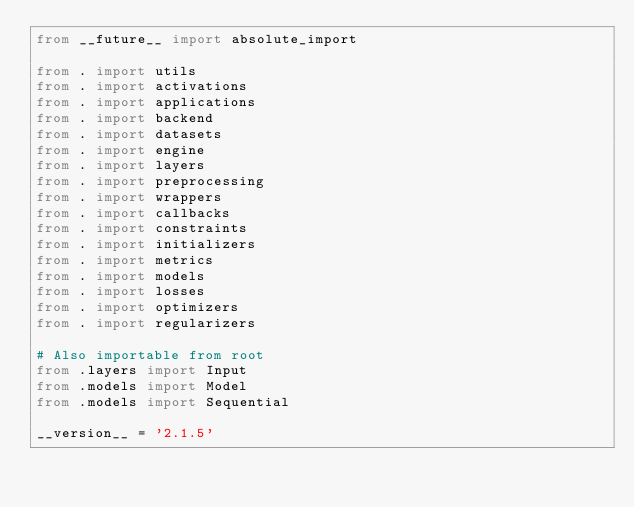Convert code to text. <code><loc_0><loc_0><loc_500><loc_500><_Python_>from __future__ import absolute_import

from . import utils
from . import activations
from . import applications
from . import backend
from . import datasets
from . import engine
from . import layers
from . import preprocessing
from . import wrappers
from . import callbacks
from . import constraints
from . import initializers
from . import metrics
from . import models
from . import losses
from . import optimizers
from . import regularizers

# Also importable from root
from .layers import Input
from .models import Model
from .models import Sequential

__version__ = '2.1.5'
</code> 